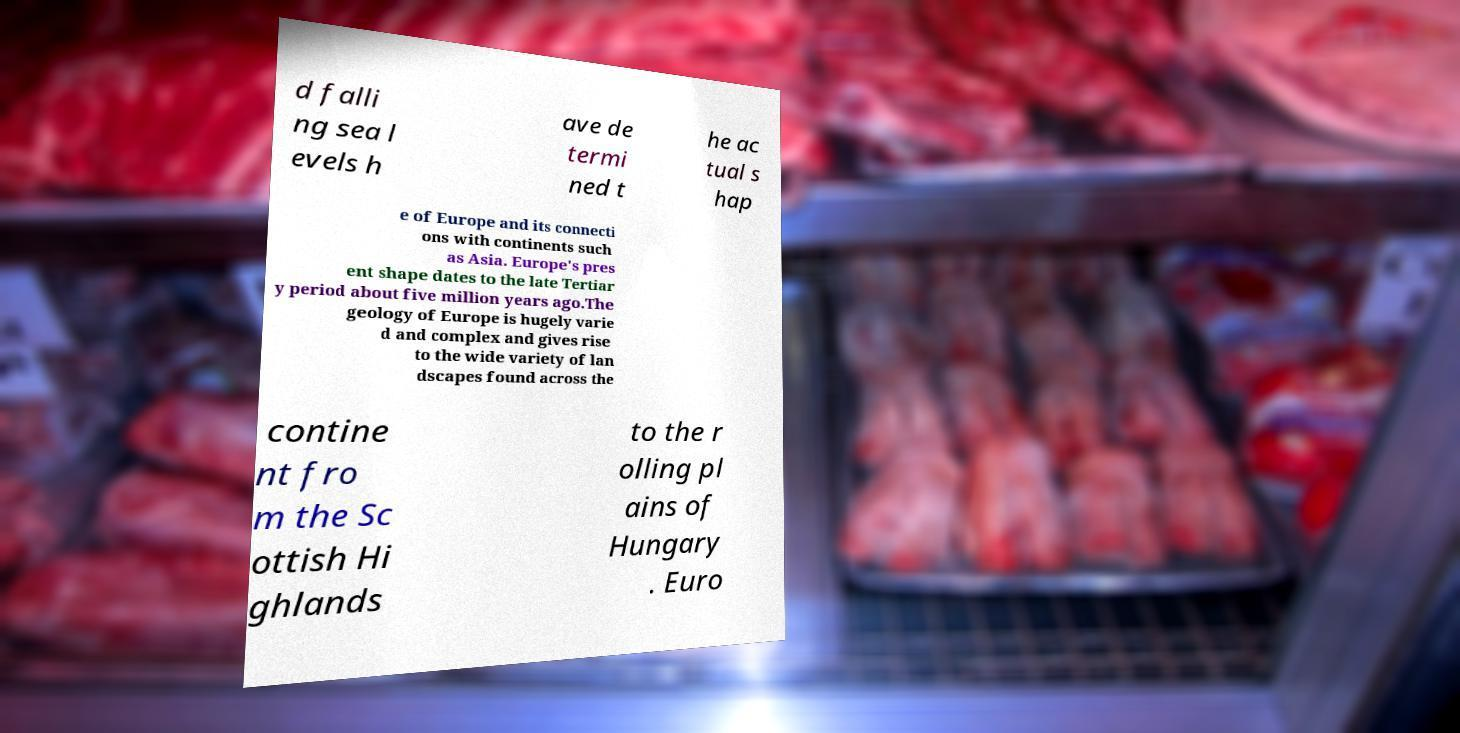Could you extract and type out the text from this image? d falli ng sea l evels h ave de termi ned t he ac tual s hap e of Europe and its connecti ons with continents such as Asia. Europe's pres ent shape dates to the late Tertiar y period about five million years ago.The geology of Europe is hugely varie d and complex and gives rise to the wide variety of lan dscapes found across the contine nt fro m the Sc ottish Hi ghlands to the r olling pl ains of Hungary . Euro 